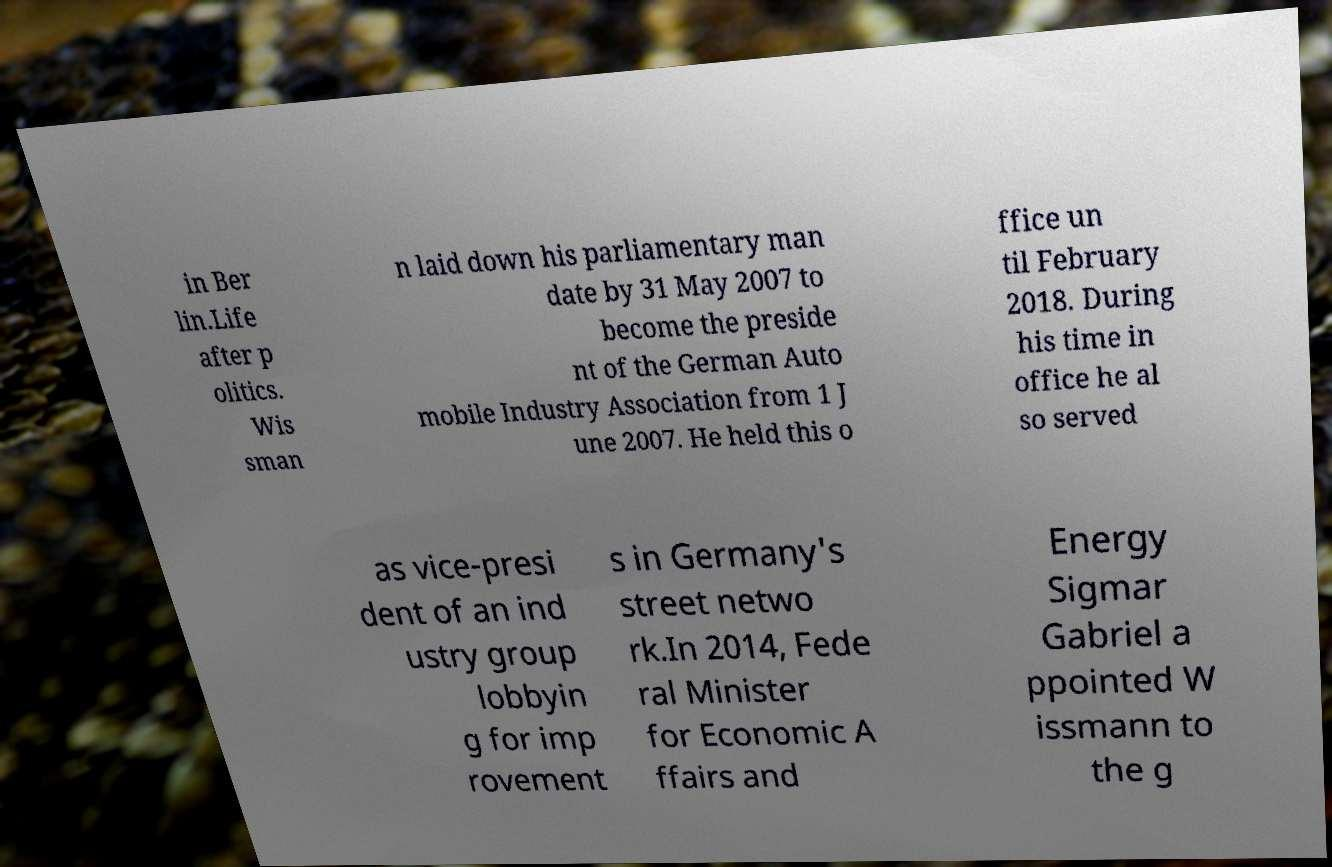For documentation purposes, I need the text within this image transcribed. Could you provide that? in Ber lin.Life after p olitics. Wis sman n laid down his parliamentary man date by 31 May 2007 to become the preside nt of the German Auto mobile Industry Association from 1 J une 2007. He held this o ffice un til February 2018. During his time in office he al so served as vice-presi dent of an ind ustry group lobbyin g for imp rovement s in Germany's street netwo rk.In 2014, Fede ral Minister for Economic A ffairs and Energy Sigmar Gabriel a ppointed W issmann to the g 